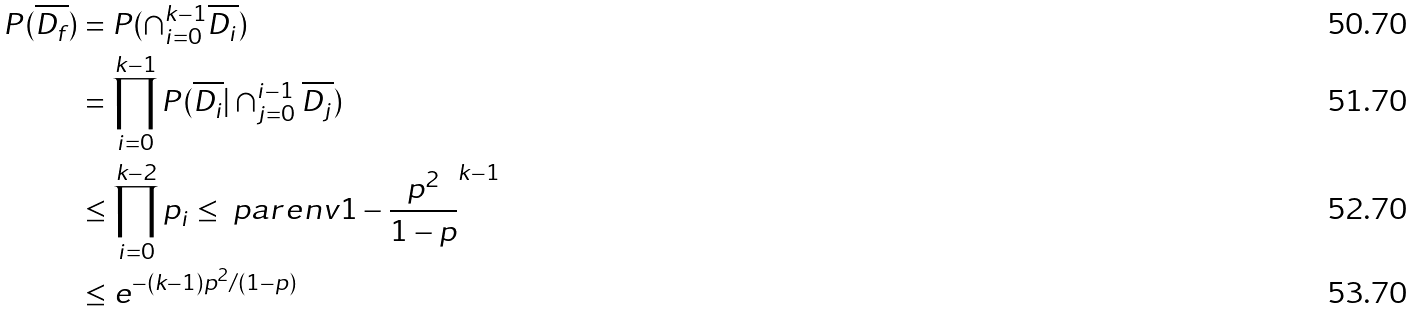Convert formula to latex. <formula><loc_0><loc_0><loc_500><loc_500>P ( \overline { D _ { f } } ) & = P ( \cap _ { i = 0 } ^ { k - 1 } \overline { D _ { i } } ) \\ & = \prod _ { i = 0 } ^ { k - 1 } P ( \overline { D _ { i } } | \cap _ { j = 0 } ^ { i - 1 } \overline { D _ { j } } ) \\ & \leq \prod _ { i = 0 } ^ { k - 2 } p _ { i } \leq \ p a r e n v { 1 - \frac { p ^ { 2 } } { 1 - p } } ^ { k - 1 } \\ & \leq e ^ { - ( k - 1 ) p ^ { 2 } / ( 1 - p ) }</formula> 